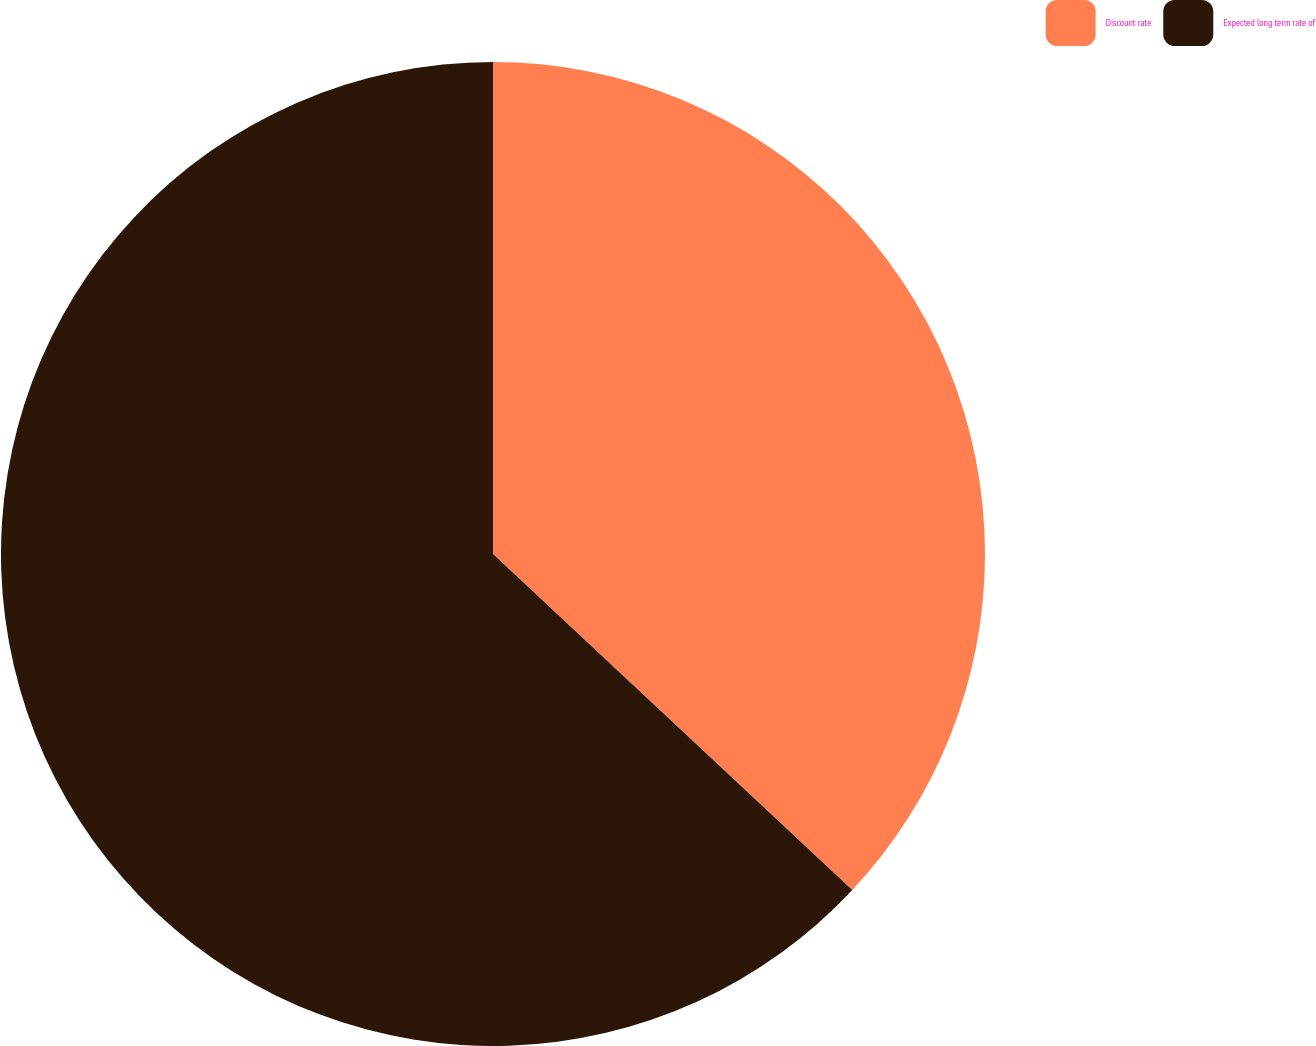Convert chart to OTSL. <chart><loc_0><loc_0><loc_500><loc_500><pie_chart><fcel>Discount rate<fcel>Expected long term rate of<nl><fcel>36.97%<fcel>63.03%<nl></chart> 